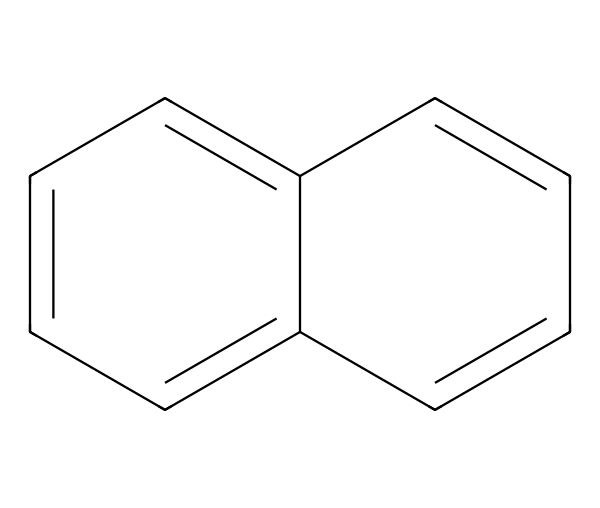What is the molecular formula of this compound? To find the molecular formula, we count the number of carbon (C) and hydrogen (H) atoms in the structure depicted by the SMILES. In this case, there are 12 carbon atoms and 10 hydrogen atoms.
Answer: C12H10 How many rings are present in the structure? By observing the connections and their arrangements, we can see that there are two interconnected aromatic rings in this compound, indicating that it is bicyclic.
Answer: 2 What type of carbon isotope is commonly found in coal? The most prevalent isotopes of carbon found in coal are Carbon-12 and Carbon-13, with Carbon-12 being the most abundant.
Answer: Carbon-12 What is the hybridization of the carbon atoms in this structure? The carbon atoms in the aromatic rings are sp2 hybridized due to the presence of double bonds, this allows for planar structure and delocalization of electrons.
Answer: sp2 What is the significance of isotopic composition in coal? The isotopic composition of carbon in coal can provide information about the origins and age of the coal, making it important for studies in geology and paleoclimatology.
Answer: origin and age How many double bonds are in this structure? By analyzing the structure, we can identify that there are 6 double bonds present that contribute to the stability and resonance of the aromatic rings.
Answer: 6 What property of the isotopes of carbon can influence the combustion efficiency in steam engines? The ratio of Carbon-12 to Carbon-13 can affect the combustion characteristics and energy output, as different isotopes may release energy differently upon burning.
Answer: combustion efficiency 